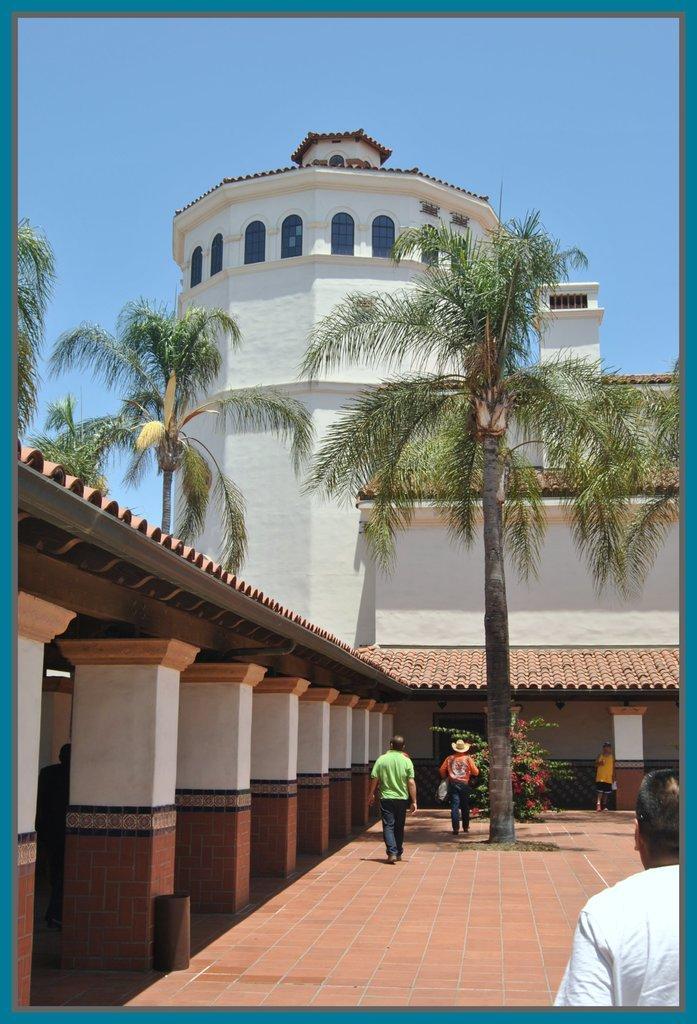Can you describe this image briefly? In this image there is a building and we can see trees. At the bottom we can see pillars and there are people. In the background there is sky. 